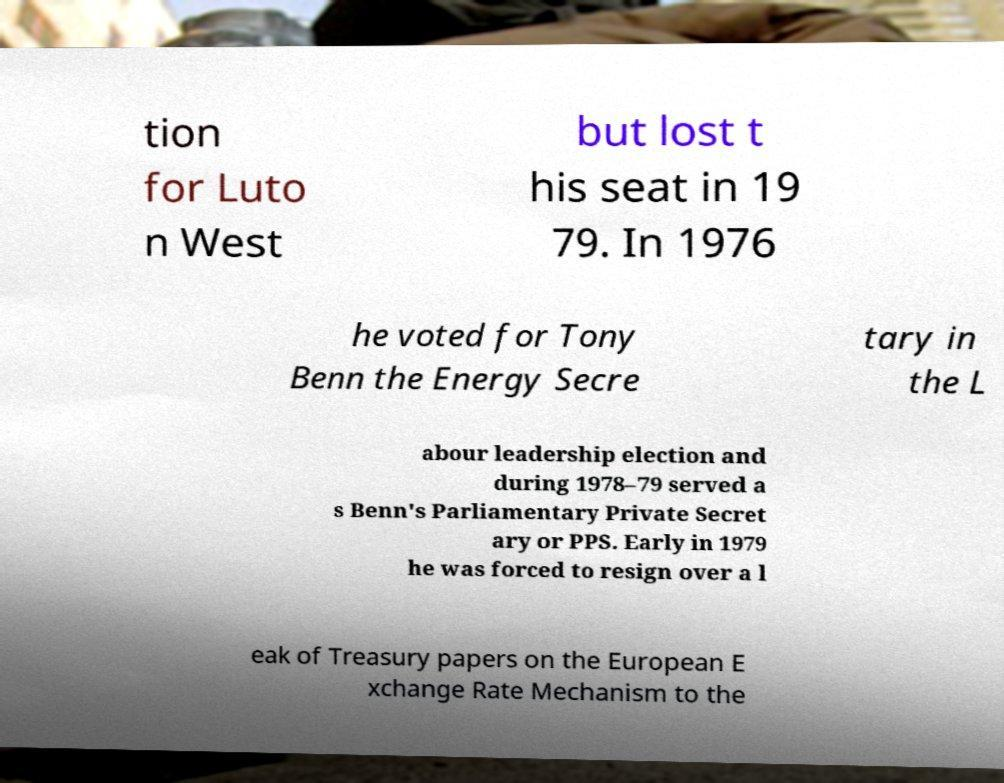What messages or text are displayed in this image? I need them in a readable, typed format. tion for Luto n West but lost t his seat in 19 79. In 1976 he voted for Tony Benn the Energy Secre tary in the L abour leadership election and during 1978–79 served a s Benn's Parliamentary Private Secret ary or PPS. Early in 1979 he was forced to resign over a l eak of Treasury papers on the European E xchange Rate Mechanism to the 